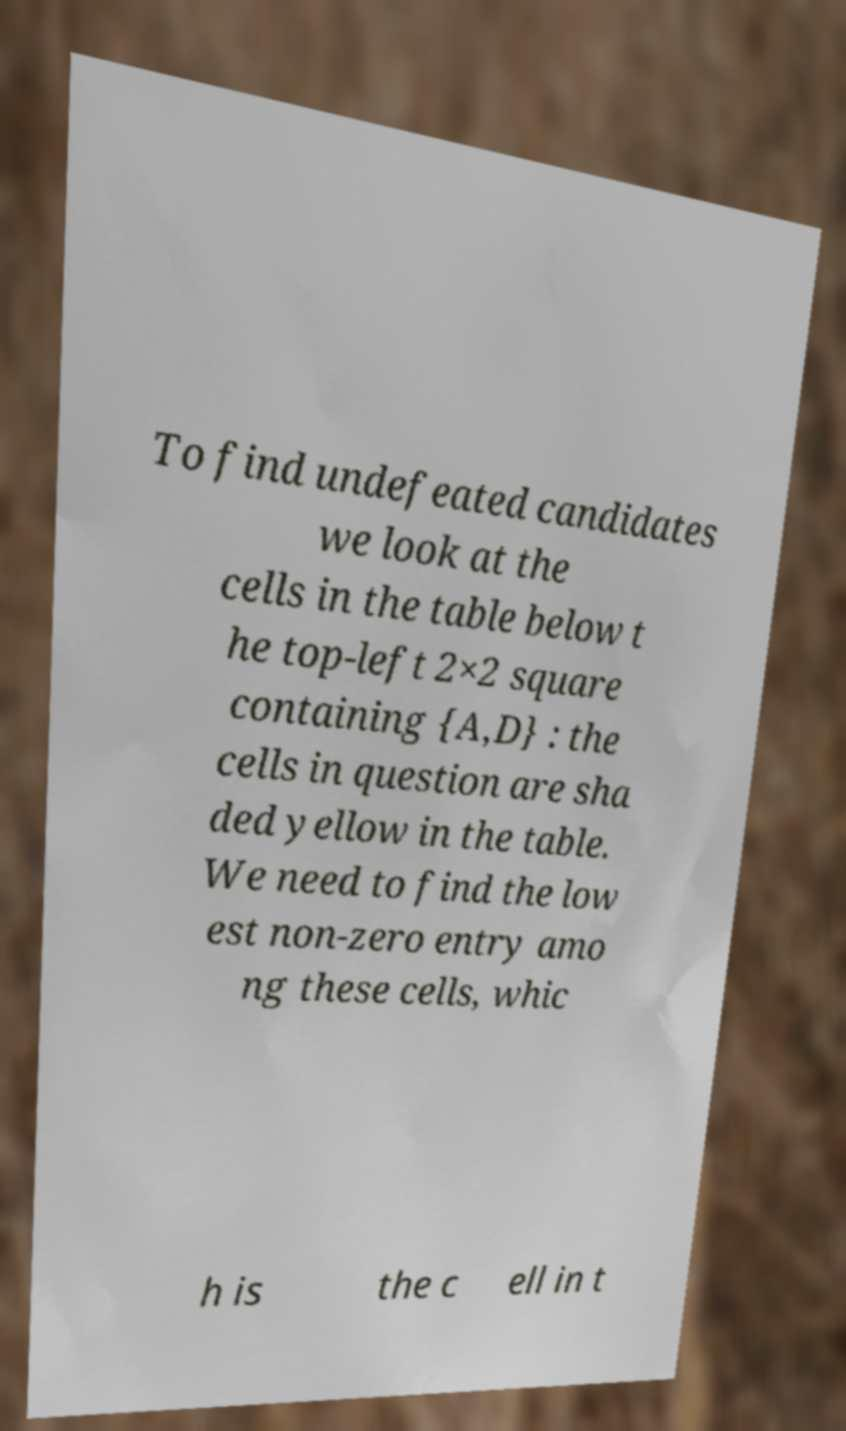Can you accurately transcribe the text from the provided image for me? To find undefeated candidates we look at the cells in the table below t he top-left 2×2 square containing {A,D} : the cells in question are sha ded yellow in the table. We need to find the low est non-zero entry amo ng these cells, whic h is the c ell in t 